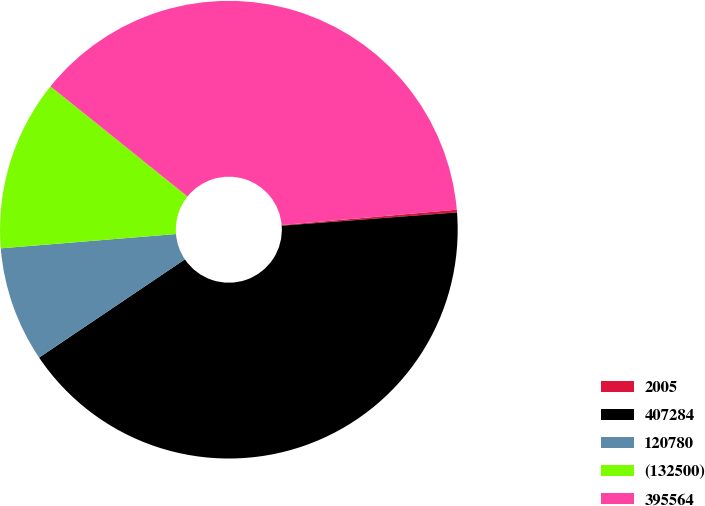Convert chart to OTSL. <chart><loc_0><loc_0><loc_500><loc_500><pie_chart><fcel>2005<fcel>407284<fcel>120780<fcel>(132500)<fcel>395564<nl><fcel>0.19%<fcel>41.76%<fcel>8.14%<fcel>12.07%<fcel>37.83%<nl></chart> 